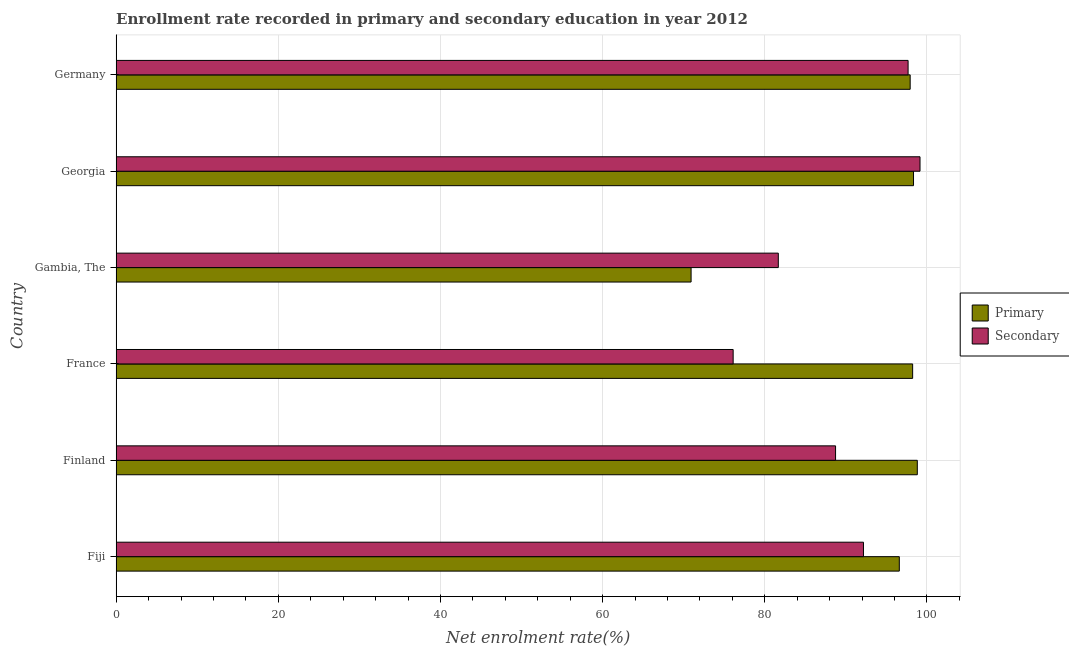How many different coloured bars are there?
Make the answer very short. 2. How many groups of bars are there?
Your answer should be very brief. 6. Are the number of bars per tick equal to the number of legend labels?
Make the answer very short. Yes. Are the number of bars on each tick of the Y-axis equal?
Offer a terse response. Yes. How many bars are there on the 1st tick from the top?
Your answer should be compact. 2. In how many cases, is the number of bars for a given country not equal to the number of legend labels?
Ensure brevity in your answer.  0. What is the enrollment rate in primary education in Gambia, The?
Ensure brevity in your answer.  70.91. Across all countries, what is the maximum enrollment rate in primary education?
Your response must be concise. 98.81. Across all countries, what is the minimum enrollment rate in primary education?
Make the answer very short. 70.91. In which country was the enrollment rate in primary education minimum?
Provide a succinct answer. Gambia, The. What is the total enrollment rate in secondary education in the graph?
Provide a short and direct response. 535.5. What is the difference between the enrollment rate in secondary education in Fiji and that in France?
Provide a short and direct response. 16.07. What is the difference between the enrollment rate in primary education in Finland and the enrollment rate in secondary education in Gambia, The?
Your answer should be very brief. 17.14. What is the average enrollment rate in primary education per country?
Your answer should be compact. 93.47. What is the difference between the enrollment rate in primary education and enrollment rate in secondary education in France?
Your answer should be compact. 22.14. What is the ratio of the enrollment rate in secondary education in Gambia, The to that in Germany?
Offer a very short reply. 0.84. Is the difference between the enrollment rate in primary education in Finland and Gambia, The greater than the difference between the enrollment rate in secondary education in Finland and Gambia, The?
Provide a succinct answer. Yes. What is the difference between the highest and the second highest enrollment rate in secondary education?
Your response must be concise. 1.47. What is the difference between the highest and the lowest enrollment rate in primary education?
Make the answer very short. 27.9. Is the sum of the enrollment rate in primary education in Gambia, The and Germany greater than the maximum enrollment rate in secondary education across all countries?
Make the answer very short. Yes. What does the 2nd bar from the top in Germany represents?
Offer a terse response. Primary. What does the 1st bar from the bottom in Georgia represents?
Provide a succinct answer. Primary. How many bars are there?
Offer a terse response. 12. Does the graph contain grids?
Offer a very short reply. Yes. Where does the legend appear in the graph?
Offer a very short reply. Center right. What is the title of the graph?
Keep it short and to the point. Enrollment rate recorded in primary and secondary education in year 2012. Does "Stunting" appear as one of the legend labels in the graph?
Make the answer very short. No. What is the label or title of the X-axis?
Keep it short and to the point. Net enrolment rate(%). What is the Net enrolment rate(%) of Primary in Fiji?
Make the answer very short. 96.59. What is the Net enrolment rate(%) of Secondary in Fiji?
Keep it short and to the point. 92.17. What is the Net enrolment rate(%) of Primary in Finland?
Your answer should be compact. 98.81. What is the Net enrolment rate(%) in Secondary in Finland?
Give a very brief answer. 88.73. What is the Net enrolment rate(%) of Primary in France?
Make the answer very short. 98.24. What is the Net enrolment rate(%) in Secondary in France?
Your response must be concise. 76.1. What is the Net enrolment rate(%) in Primary in Gambia, The?
Make the answer very short. 70.91. What is the Net enrolment rate(%) in Secondary in Gambia, The?
Offer a very short reply. 81.67. What is the Net enrolment rate(%) in Primary in Georgia?
Offer a terse response. 98.35. What is the Net enrolment rate(%) of Secondary in Georgia?
Provide a succinct answer. 99.15. What is the Net enrolment rate(%) of Primary in Germany?
Offer a terse response. 97.93. What is the Net enrolment rate(%) in Secondary in Germany?
Keep it short and to the point. 97.68. Across all countries, what is the maximum Net enrolment rate(%) of Primary?
Your answer should be very brief. 98.81. Across all countries, what is the maximum Net enrolment rate(%) in Secondary?
Provide a succinct answer. 99.15. Across all countries, what is the minimum Net enrolment rate(%) in Primary?
Your answer should be compact. 70.91. Across all countries, what is the minimum Net enrolment rate(%) of Secondary?
Offer a very short reply. 76.1. What is the total Net enrolment rate(%) of Primary in the graph?
Make the answer very short. 560.84. What is the total Net enrolment rate(%) of Secondary in the graph?
Your answer should be very brief. 535.5. What is the difference between the Net enrolment rate(%) of Primary in Fiji and that in Finland?
Ensure brevity in your answer.  -2.22. What is the difference between the Net enrolment rate(%) in Secondary in Fiji and that in Finland?
Give a very brief answer. 3.44. What is the difference between the Net enrolment rate(%) of Primary in Fiji and that in France?
Ensure brevity in your answer.  -1.64. What is the difference between the Net enrolment rate(%) in Secondary in Fiji and that in France?
Provide a short and direct response. 16.07. What is the difference between the Net enrolment rate(%) in Primary in Fiji and that in Gambia, The?
Your response must be concise. 25.68. What is the difference between the Net enrolment rate(%) of Secondary in Fiji and that in Gambia, The?
Provide a succinct answer. 10.5. What is the difference between the Net enrolment rate(%) in Primary in Fiji and that in Georgia?
Your response must be concise. -1.75. What is the difference between the Net enrolment rate(%) of Secondary in Fiji and that in Georgia?
Offer a very short reply. -6.97. What is the difference between the Net enrolment rate(%) of Primary in Fiji and that in Germany?
Your response must be concise. -1.34. What is the difference between the Net enrolment rate(%) in Secondary in Fiji and that in Germany?
Give a very brief answer. -5.5. What is the difference between the Net enrolment rate(%) of Primary in Finland and that in France?
Give a very brief answer. 0.58. What is the difference between the Net enrolment rate(%) of Secondary in Finland and that in France?
Provide a succinct answer. 12.63. What is the difference between the Net enrolment rate(%) in Primary in Finland and that in Gambia, The?
Provide a succinct answer. 27.9. What is the difference between the Net enrolment rate(%) of Secondary in Finland and that in Gambia, The?
Keep it short and to the point. 7.06. What is the difference between the Net enrolment rate(%) of Primary in Finland and that in Georgia?
Offer a terse response. 0.47. What is the difference between the Net enrolment rate(%) of Secondary in Finland and that in Georgia?
Your response must be concise. -10.42. What is the difference between the Net enrolment rate(%) of Primary in Finland and that in Germany?
Your answer should be very brief. 0.88. What is the difference between the Net enrolment rate(%) of Secondary in Finland and that in Germany?
Provide a succinct answer. -8.95. What is the difference between the Net enrolment rate(%) of Primary in France and that in Gambia, The?
Ensure brevity in your answer.  27.33. What is the difference between the Net enrolment rate(%) in Secondary in France and that in Gambia, The?
Ensure brevity in your answer.  -5.57. What is the difference between the Net enrolment rate(%) in Primary in France and that in Georgia?
Provide a short and direct response. -0.11. What is the difference between the Net enrolment rate(%) of Secondary in France and that in Georgia?
Your answer should be very brief. -23.05. What is the difference between the Net enrolment rate(%) of Primary in France and that in Germany?
Your answer should be compact. 0.31. What is the difference between the Net enrolment rate(%) in Secondary in France and that in Germany?
Your response must be concise. -21.58. What is the difference between the Net enrolment rate(%) in Primary in Gambia, The and that in Georgia?
Provide a succinct answer. -27.43. What is the difference between the Net enrolment rate(%) in Secondary in Gambia, The and that in Georgia?
Your answer should be compact. -17.48. What is the difference between the Net enrolment rate(%) of Primary in Gambia, The and that in Germany?
Offer a terse response. -27.02. What is the difference between the Net enrolment rate(%) in Secondary in Gambia, The and that in Germany?
Offer a very short reply. -16.01. What is the difference between the Net enrolment rate(%) of Primary in Georgia and that in Germany?
Offer a terse response. 0.41. What is the difference between the Net enrolment rate(%) in Secondary in Georgia and that in Germany?
Your answer should be very brief. 1.47. What is the difference between the Net enrolment rate(%) of Primary in Fiji and the Net enrolment rate(%) of Secondary in Finland?
Offer a very short reply. 7.86. What is the difference between the Net enrolment rate(%) of Primary in Fiji and the Net enrolment rate(%) of Secondary in France?
Provide a succinct answer. 20.49. What is the difference between the Net enrolment rate(%) in Primary in Fiji and the Net enrolment rate(%) in Secondary in Gambia, The?
Make the answer very short. 14.92. What is the difference between the Net enrolment rate(%) in Primary in Fiji and the Net enrolment rate(%) in Secondary in Georgia?
Provide a short and direct response. -2.55. What is the difference between the Net enrolment rate(%) in Primary in Fiji and the Net enrolment rate(%) in Secondary in Germany?
Keep it short and to the point. -1.08. What is the difference between the Net enrolment rate(%) in Primary in Finland and the Net enrolment rate(%) in Secondary in France?
Provide a short and direct response. 22.71. What is the difference between the Net enrolment rate(%) in Primary in Finland and the Net enrolment rate(%) in Secondary in Gambia, The?
Offer a very short reply. 17.14. What is the difference between the Net enrolment rate(%) of Primary in Finland and the Net enrolment rate(%) of Secondary in Georgia?
Give a very brief answer. -0.33. What is the difference between the Net enrolment rate(%) of Primary in Finland and the Net enrolment rate(%) of Secondary in Germany?
Your answer should be very brief. 1.14. What is the difference between the Net enrolment rate(%) in Primary in France and the Net enrolment rate(%) in Secondary in Gambia, The?
Your answer should be very brief. 16.57. What is the difference between the Net enrolment rate(%) of Primary in France and the Net enrolment rate(%) of Secondary in Georgia?
Your response must be concise. -0.91. What is the difference between the Net enrolment rate(%) in Primary in France and the Net enrolment rate(%) in Secondary in Germany?
Keep it short and to the point. 0.56. What is the difference between the Net enrolment rate(%) in Primary in Gambia, The and the Net enrolment rate(%) in Secondary in Georgia?
Your response must be concise. -28.23. What is the difference between the Net enrolment rate(%) of Primary in Gambia, The and the Net enrolment rate(%) of Secondary in Germany?
Offer a terse response. -26.76. What is the difference between the Net enrolment rate(%) in Primary in Georgia and the Net enrolment rate(%) in Secondary in Germany?
Offer a very short reply. 0.67. What is the average Net enrolment rate(%) in Primary per country?
Your answer should be compact. 93.47. What is the average Net enrolment rate(%) of Secondary per country?
Ensure brevity in your answer.  89.25. What is the difference between the Net enrolment rate(%) of Primary and Net enrolment rate(%) of Secondary in Fiji?
Offer a very short reply. 4.42. What is the difference between the Net enrolment rate(%) in Primary and Net enrolment rate(%) in Secondary in Finland?
Your answer should be compact. 10.08. What is the difference between the Net enrolment rate(%) of Primary and Net enrolment rate(%) of Secondary in France?
Offer a terse response. 22.14. What is the difference between the Net enrolment rate(%) in Primary and Net enrolment rate(%) in Secondary in Gambia, The?
Make the answer very short. -10.76. What is the difference between the Net enrolment rate(%) in Primary and Net enrolment rate(%) in Secondary in Georgia?
Ensure brevity in your answer.  -0.8. What is the difference between the Net enrolment rate(%) in Primary and Net enrolment rate(%) in Secondary in Germany?
Provide a short and direct response. 0.26. What is the ratio of the Net enrolment rate(%) of Primary in Fiji to that in Finland?
Your response must be concise. 0.98. What is the ratio of the Net enrolment rate(%) in Secondary in Fiji to that in Finland?
Give a very brief answer. 1.04. What is the ratio of the Net enrolment rate(%) of Primary in Fiji to that in France?
Your response must be concise. 0.98. What is the ratio of the Net enrolment rate(%) in Secondary in Fiji to that in France?
Give a very brief answer. 1.21. What is the ratio of the Net enrolment rate(%) of Primary in Fiji to that in Gambia, The?
Your response must be concise. 1.36. What is the ratio of the Net enrolment rate(%) of Secondary in Fiji to that in Gambia, The?
Make the answer very short. 1.13. What is the ratio of the Net enrolment rate(%) in Primary in Fiji to that in Georgia?
Provide a short and direct response. 0.98. What is the ratio of the Net enrolment rate(%) of Secondary in Fiji to that in Georgia?
Give a very brief answer. 0.93. What is the ratio of the Net enrolment rate(%) in Primary in Fiji to that in Germany?
Offer a terse response. 0.99. What is the ratio of the Net enrolment rate(%) in Secondary in Fiji to that in Germany?
Offer a terse response. 0.94. What is the ratio of the Net enrolment rate(%) in Primary in Finland to that in France?
Your answer should be very brief. 1.01. What is the ratio of the Net enrolment rate(%) in Secondary in Finland to that in France?
Give a very brief answer. 1.17. What is the ratio of the Net enrolment rate(%) in Primary in Finland to that in Gambia, The?
Offer a terse response. 1.39. What is the ratio of the Net enrolment rate(%) in Secondary in Finland to that in Gambia, The?
Give a very brief answer. 1.09. What is the ratio of the Net enrolment rate(%) in Primary in Finland to that in Georgia?
Give a very brief answer. 1. What is the ratio of the Net enrolment rate(%) in Secondary in Finland to that in Georgia?
Give a very brief answer. 0.89. What is the ratio of the Net enrolment rate(%) of Primary in Finland to that in Germany?
Keep it short and to the point. 1.01. What is the ratio of the Net enrolment rate(%) of Secondary in Finland to that in Germany?
Make the answer very short. 0.91. What is the ratio of the Net enrolment rate(%) in Primary in France to that in Gambia, The?
Give a very brief answer. 1.39. What is the ratio of the Net enrolment rate(%) in Secondary in France to that in Gambia, The?
Provide a succinct answer. 0.93. What is the ratio of the Net enrolment rate(%) of Secondary in France to that in Georgia?
Provide a short and direct response. 0.77. What is the ratio of the Net enrolment rate(%) in Primary in France to that in Germany?
Make the answer very short. 1. What is the ratio of the Net enrolment rate(%) in Secondary in France to that in Germany?
Your response must be concise. 0.78. What is the ratio of the Net enrolment rate(%) in Primary in Gambia, The to that in Georgia?
Provide a succinct answer. 0.72. What is the ratio of the Net enrolment rate(%) of Secondary in Gambia, The to that in Georgia?
Offer a terse response. 0.82. What is the ratio of the Net enrolment rate(%) of Primary in Gambia, The to that in Germany?
Ensure brevity in your answer.  0.72. What is the ratio of the Net enrolment rate(%) of Secondary in Gambia, The to that in Germany?
Your response must be concise. 0.84. What is the ratio of the Net enrolment rate(%) in Primary in Georgia to that in Germany?
Give a very brief answer. 1. What is the ratio of the Net enrolment rate(%) in Secondary in Georgia to that in Germany?
Give a very brief answer. 1.02. What is the difference between the highest and the second highest Net enrolment rate(%) in Primary?
Keep it short and to the point. 0.47. What is the difference between the highest and the second highest Net enrolment rate(%) in Secondary?
Your response must be concise. 1.47. What is the difference between the highest and the lowest Net enrolment rate(%) of Primary?
Your answer should be very brief. 27.9. What is the difference between the highest and the lowest Net enrolment rate(%) in Secondary?
Provide a short and direct response. 23.05. 